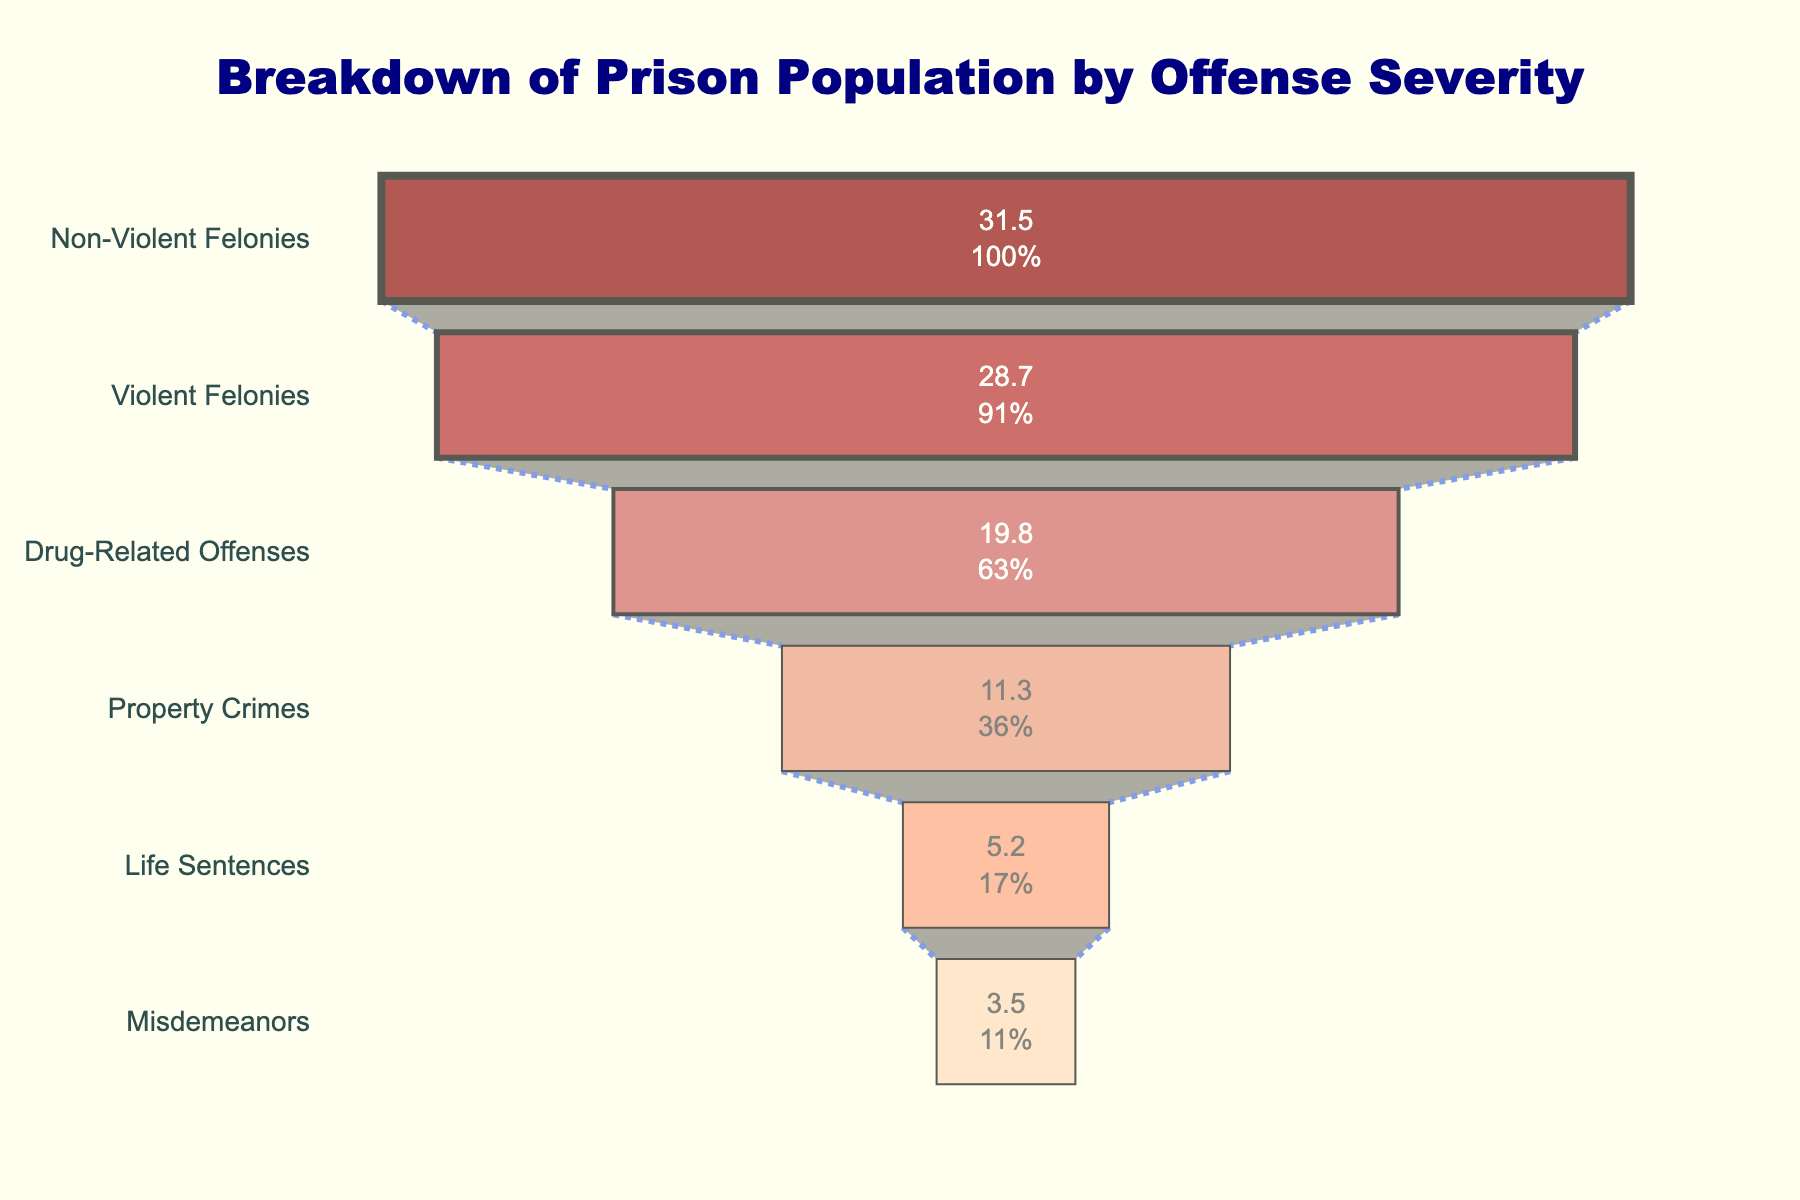What's the title of the chart? The title of the chart is located at the top of the figure. It reads, "Breakdown of Prison Population by Offense Severity".
Answer: Breakdown of Prison Population by Offense Severity What offense type represents the largest percentage of the prison population? To determine the offense type with the largest percentage, look at the top of the funnel chart where it displays the highest value.
Answer: Non-Violent Felonies What is the combined percentage of the prison population for violent felonies and drug-related offenses? Add the percentages for violent felonies (28.7%) and drug-related offenses (19.8%) together. 28.7 + 19.8 = 48.5%
Answer: 48.5% Is the percentage of the prison population for property crimes greater than the percentage for misdemeanors? Compare the percentages for property crimes (11.3%) and misdemeanors (3.5%).
Answer: Yes What is the percentage difference between non-violent felonies and life sentences? Subtract the percentage for life sentences (5.2%) from the percentage for non-violent felonies (31.5%). 31.5 - 5.2 = 26.3%
Answer: 26.3% How many offense types are represented in the funnel chart overall? Count the number of different offense types listed on the y-axis of the funnel chart.
Answer: 6 Which offense type is the least common, and what percentage does it represent? Look at the bottom-most section of the funnel chart to identify the least common offense type and its percentage.
Answer: Misdemeanors, 3.5% By how much does the percentage of non-violent felonies exceed the percentage of violent felonies? Subtract the percentage of violent felonies (28.7%) from the percentage of non-violent felonies (31.5%). 31.5 - 28.7 = 2.8%
Answer: 2.8% Which color is used to represent life sentences in the funnel chart? Identify the color used for the section labeled "Life Sentences" in the funnel chart.
Answer: Dark red What percentage of the prison population is involved in either property crimes or misdemeanors? Add the percentages for property crimes (11.3%) and misdemeanors (3.5%) together. 11.3 + 3.5 = 14.8%
Answer: 14.8% 